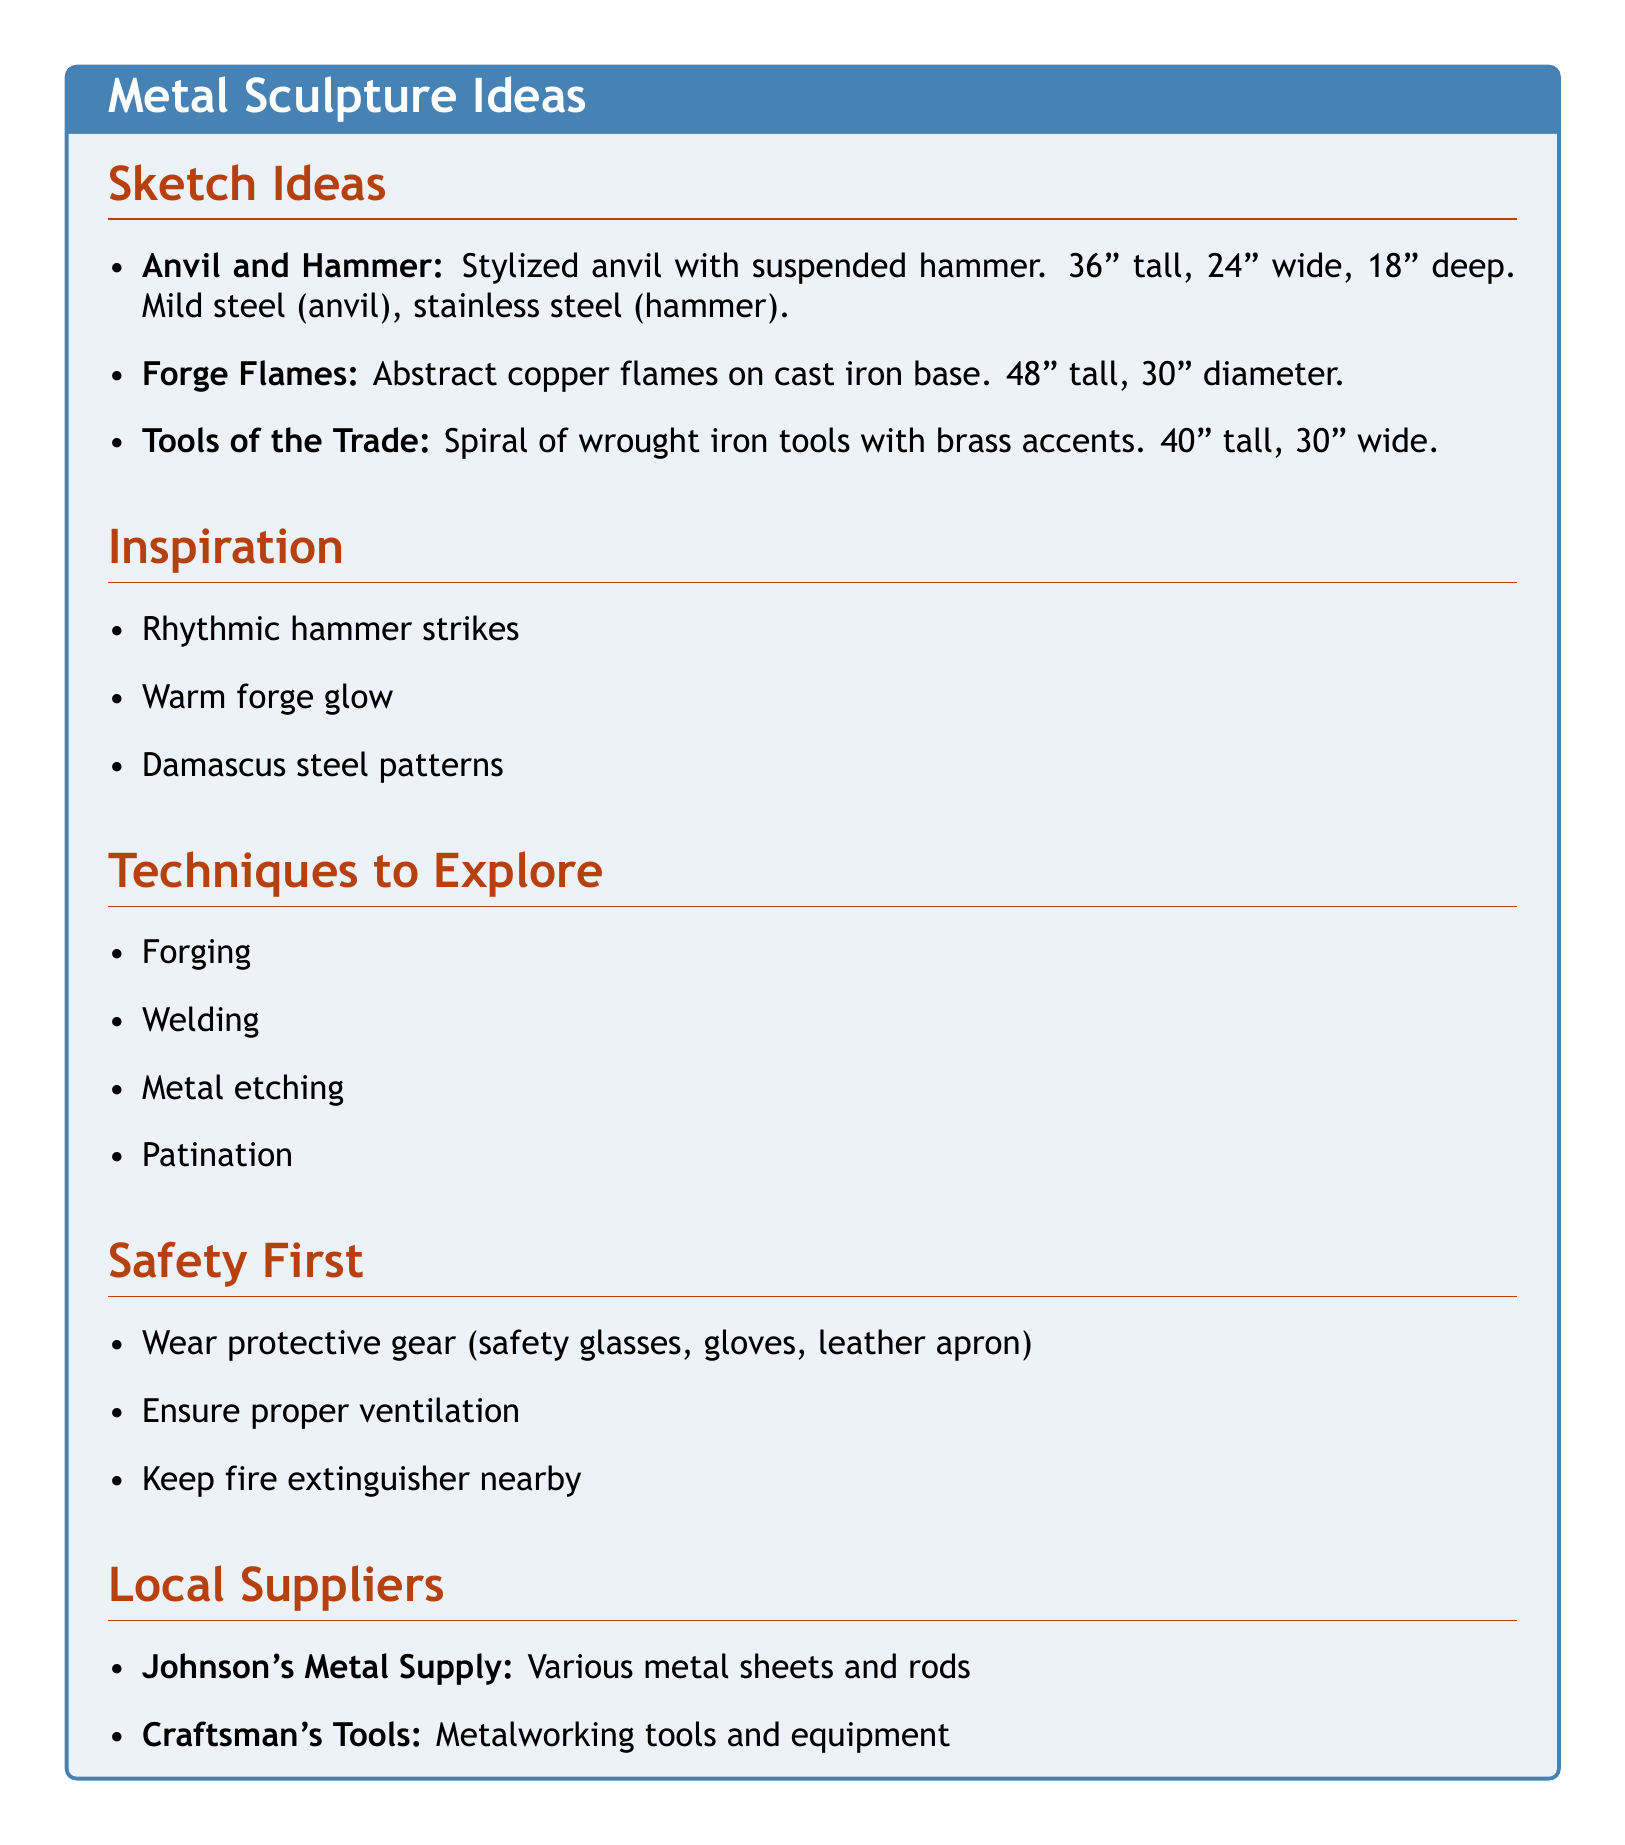What is the title of the first sketch idea? The title of the first sketch idea is "Anvil and Hammer."
Answer: Anvil and Hammer What material is used for the hammer in the "Anvil and Hammer" sculpture? The document specifies that stainless steel is used for the hammer.
Answer: Stainless steel What is the height of the "Forge Flames" sculpture? The height of the "Forge Flames" sculpture is mentioned as 48 inches tall.
Answer: 48 inches What are two techniques explored in the document? The document lists several techniques, including forging and welding.
Answer: Forging, welding What safety gear is recommended for metalworking? The document lists protective gear such as safety glasses, gloves, and a leather apron.
Answer: Safety glasses, gloves, leather apron What is the measurement of the "Tools of the Trade" sculpture in width? The width of the "Tools of the Trade" sculpture is stated as 30 inches wide.
Answer: 30 inches Which local supplier specializes in metalworking tools? The document identifies "Craftsman's Tools" as a supplier specializing in metalworking tools.
Answer: Craftsman's Tools What is the diameter of the base of the "Forge Flames"? The diameter of the base of the "Forge Flames" sculpture is 30 inches.
Answer: 30 inches What inspired the sculptures mentioned in the document? The document cites the rhythmic sound of hammer striking metal as one of the inspirations.
Answer: Rhythmic sound of hammer striking metal 